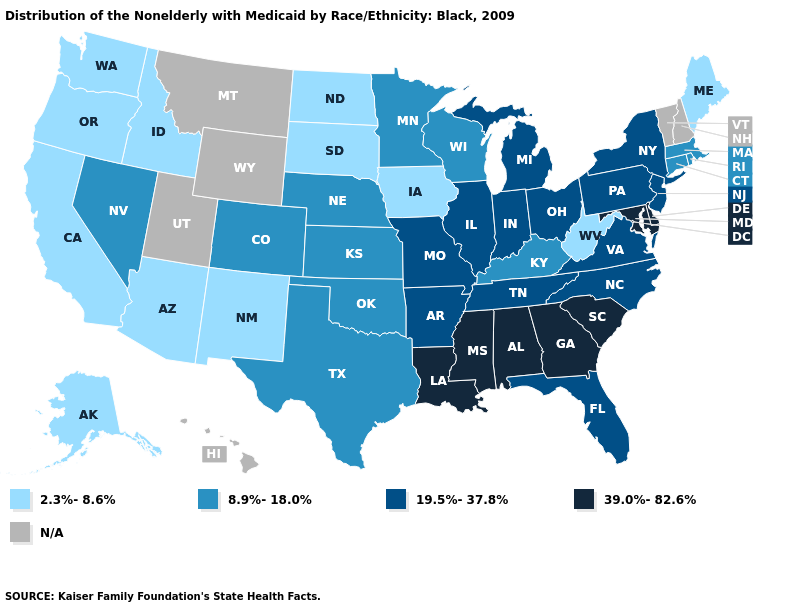Among the states that border New Mexico , which have the highest value?
Give a very brief answer. Colorado, Oklahoma, Texas. Name the states that have a value in the range 2.3%-8.6%?
Quick response, please. Alaska, Arizona, California, Idaho, Iowa, Maine, New Mexico, North Dakota, Oregon, South Dakota, Washington, West Virginia. Does the first symbol in the legend represent the smallest category?
Quick response, please. Yes. What is the value of Pennsylvania?
Answer briefly. 19.5%-37.8%. Among the states that border Louisiana , does Mississippi have the lowest value?
Quick response, please. No. Name the states that have a value in the range 19.5%-37.8%?
Be succinct. Arkansas, Florida, Illinois, Indiana, Michigan, Missouri, New Jersey, New York, North Carolina, Ohio, Pennsylvania, Tennessee, Virginia. Name the states that have a value in the range 39.0%-82.6%?
Short answer required. Alabama, Delaware, Georgia, Louisiana, Maryland, Mississippi, South Carolina. What is the value of New York?
Keep it brief. 19.5%-37.8%. Name the states that have a value in the range N/A?
Keep it brief. Hawaii, Montana, New Hampshire, Utah, Vermont, Wyoming. Which states have the highest value in the USA?
Write a very short answer. Alabama, Delaware, Georgia, Louisiana, Maryland, Mississippi, South Carolina. What is the highest value in the MidWest ?
Give a very brief answer. 19.5%-37.8%. Name the states that have a value in the range 8.9%-18.0%?
Quick response, please. Colorado, Connecticut, Kansas, Kentucky, Massachusetts, Minnesota, Nebraska, Nevada, Oklahoma, Rhode Island, Texas, Wisconsin. 